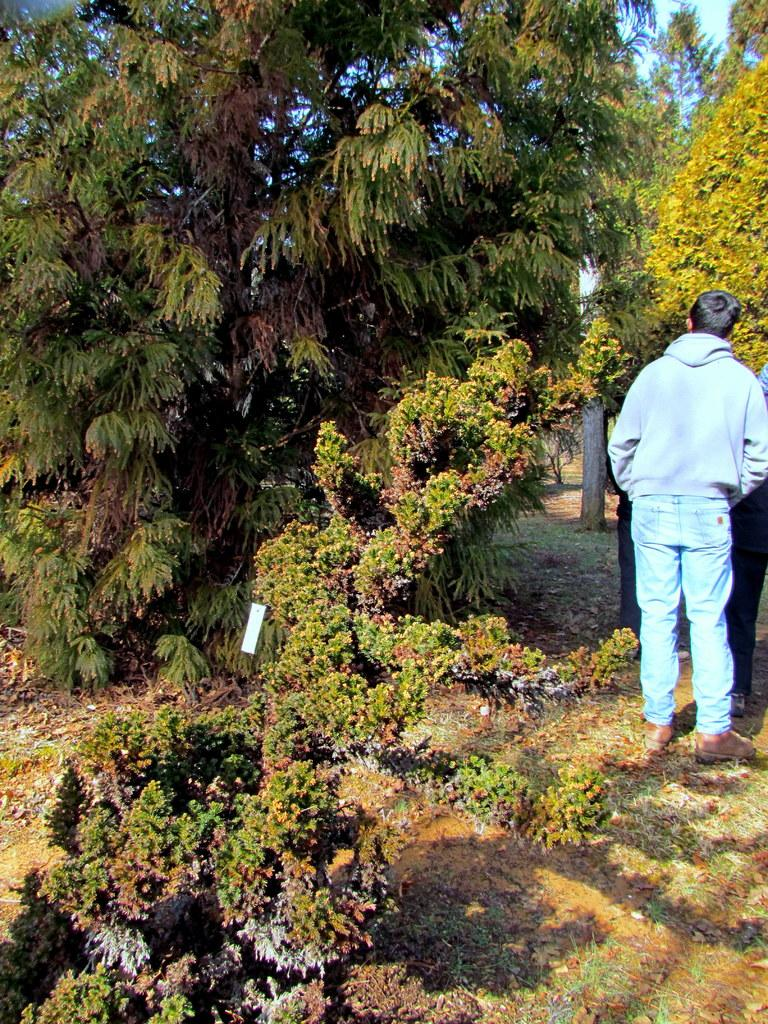What type of natural elements can be seen in the image? There are trees and plants in the image. Can you describe the people in the image? Two persons are standing on the right side of the image. What type of glass object is visible in the image? There is no glass object present in the image. What type of wax can be seen dripping from the trees in the image? There is no wax present in the image, and trees do not produce wax. 